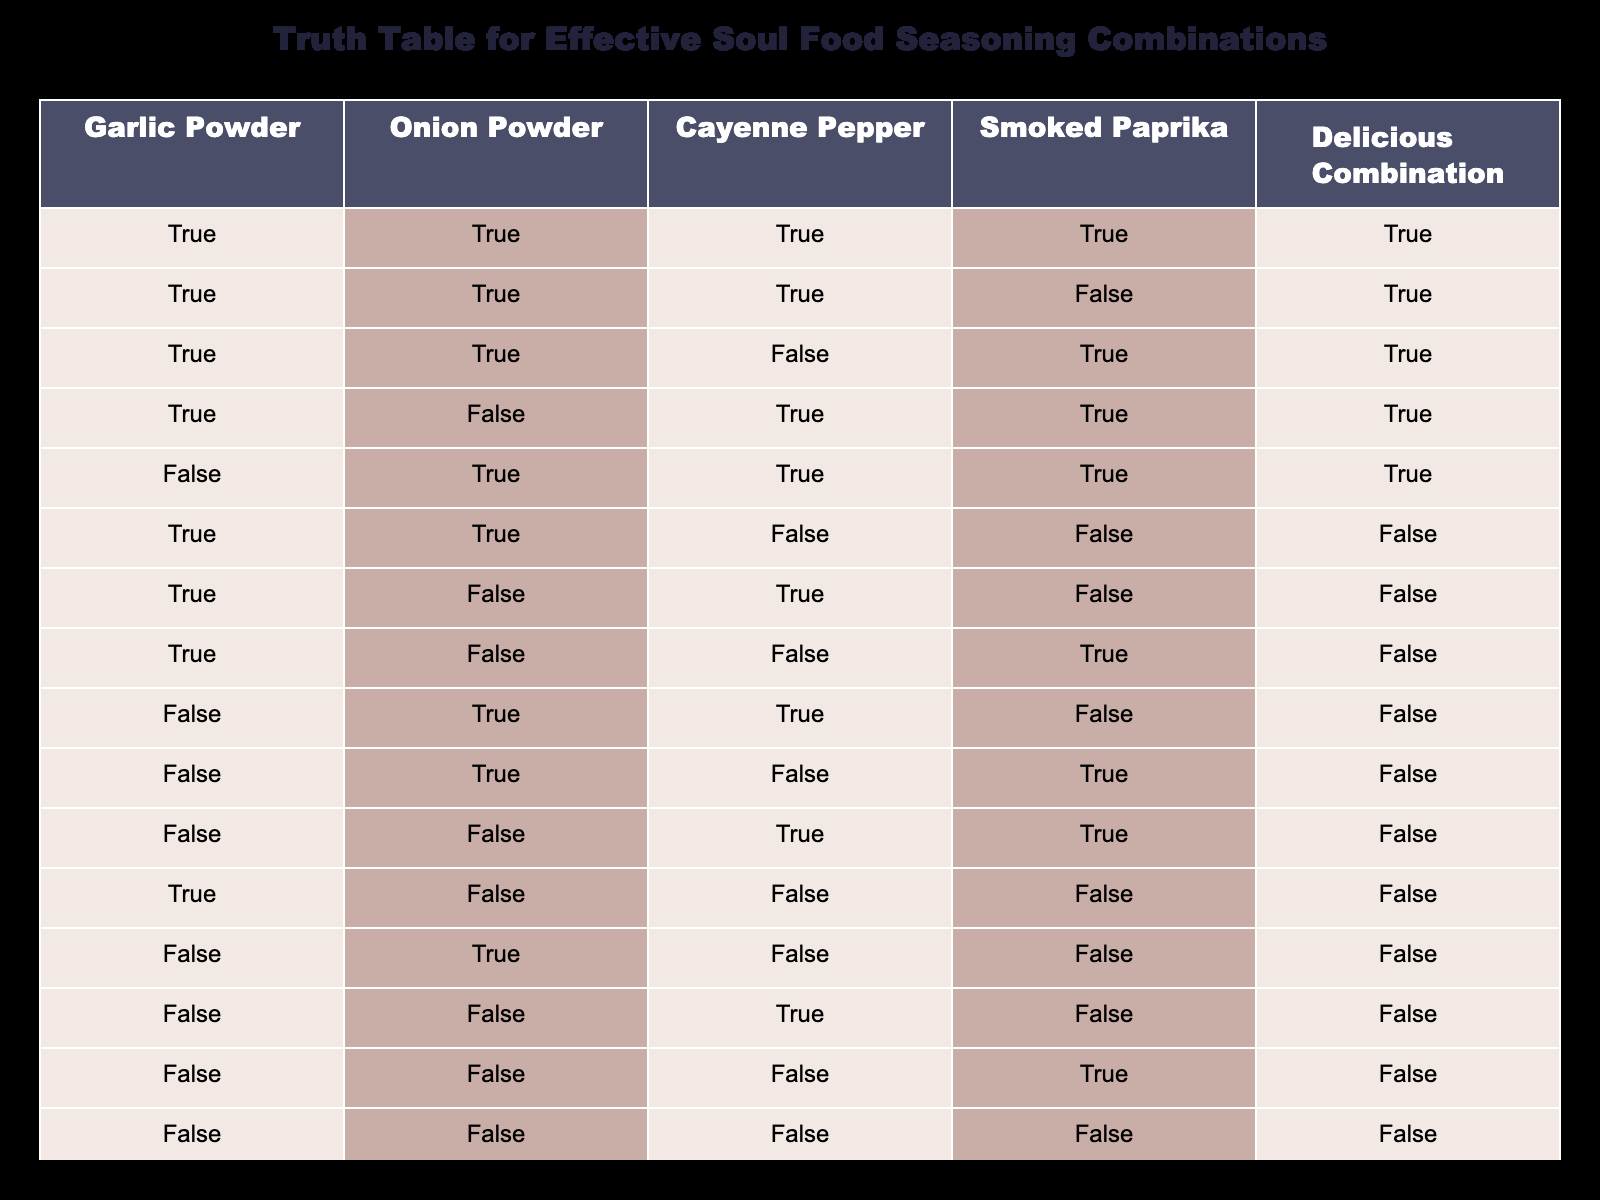What is the truth value for the combination of Garlic Powder, Onion Powder, Cayenne Pepper, and Smoked Paprika? The row corresponding to all four seasonings being true indicates a Delicious Combination, which can be found in the first row of the table. Here, all four seasoning values are marked as TRUE, leading to a Delicious Combination being TRUE.
Answer: TRUE How many combinations contain Garlic Powder and Onion Powder? To find this, we check each row where both Garlic Powder and Onion Powder are TRUE. Upon reviewing the table, there are 5 rows that satisfy this condition (the first four rows and the fifth row).
Answer: 5 Is the combination of Onion Powder and Smoked Paprika a Delicious Combination? Looking through the table, we note that both Onion Powder and Smoked Paprika must be TRUE for that row to be a Delicious Combination. We see in the fifth row that Onion Powder is TRUE and Smoked Paprika is TRUE, making the Delicious Combination TRUE as well.
Answer: YES What is the total number of Delicious Combinations? To determine this, I will count all the rows marked as TRUE in the Delicious Combination column. Scanning through the rows, there are 6 instances of TRUE (rows 1, 2, 3, 4, 5, and 6).
Answer: 6 What is the result of the combination of Garlic Powder and Smoked Paprika when Onion Powder and Cayenne Pepper are FALSE? Reviewing the table, we look for the row where Garlic Powder is TRUE and both Onion Powder and Cayenne Pepper are FALSE. This condition holds true for the eighth row, which indicates the Delicious Combination is FALSE in this situation.
Answer: FALSE Are there any combinations where Cayenne Pepper is excluded from a Delicious Combination? We need to find rows where Cayenne Pepper is FALSE and see if the Delicious Combination is TRUE. On inspection, there are three rows (row 6, 8, and 10) where Cayenne Pepper is FALSE; however, only rows 6 and 10 yield a Delicious Combination that is FALSE as well.
Answer: YES What is the Delicious Combination status when both Garlic Powder and Cayenne Pepper are TRUE while Onion Powder and Smoked Paprika are FALSE? Checking the conditions, this is seen in row 7. Here, Garlic Powder and Cayenne Pepper are TRUE while Onion Powder and Smoked Paprika are both FALSE. The Delicious Combination for this case is FALSE.
Answer: FALSE Which combination yields a Delicious Combination with only Smoked Paprika and excludes the others? Investigating the table, I see that whenever Smoked Paprika is TRUE while all other seasonings are FALSE, it results in a Delicious Combination status of FALSE (specifically seen in the last row).
Answer: FALSE In how many total instances does Smoked Paprika contribute to a Delicious Combination? To determine this, I will check each occurrence where Smoked Paprika is TRUE in correlation with a Delicious Combination status of TRUE across the rows. After examining the table, Smoked Paprika contributes to Delicious Combinations in 4 instances (rows 1, 2, 3, and 5).
Answer: 4 